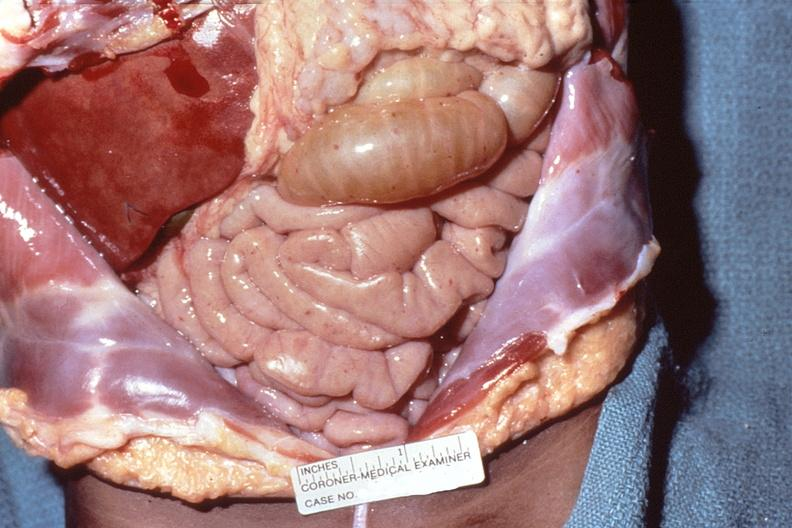does this image show meningococcemia, petechia on serosal surface of abdominal viscera?
Answer the question using a single word or phrase. Yes 